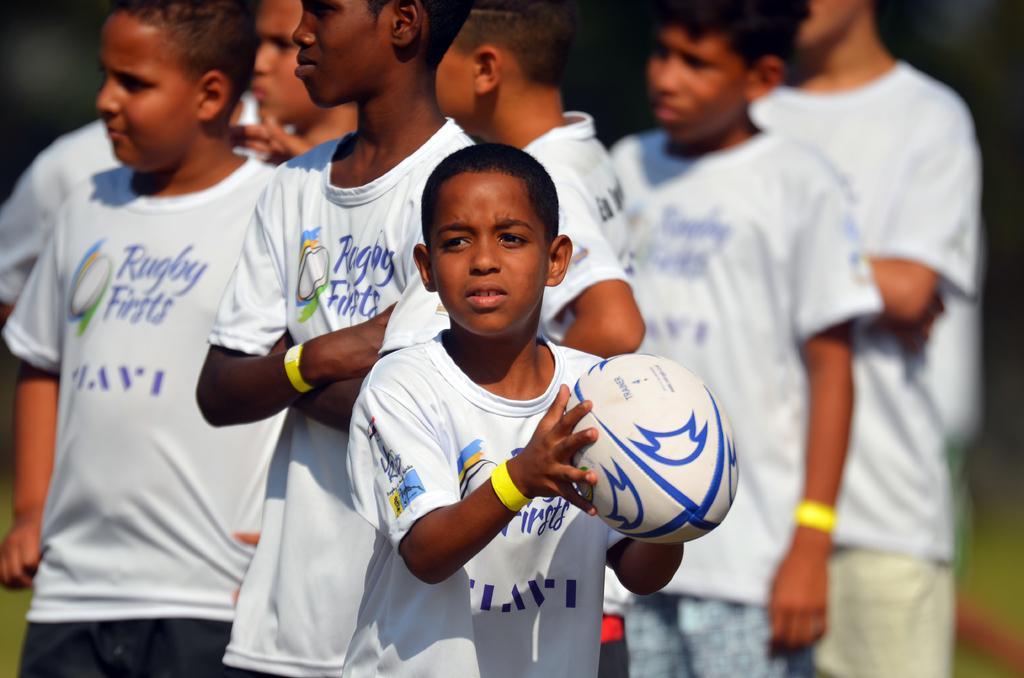Please provide a concise description of this image. In this image there is a group of kids who are wearing similar dress and at the middle of the image there is a kid catching a ball in his hands. 